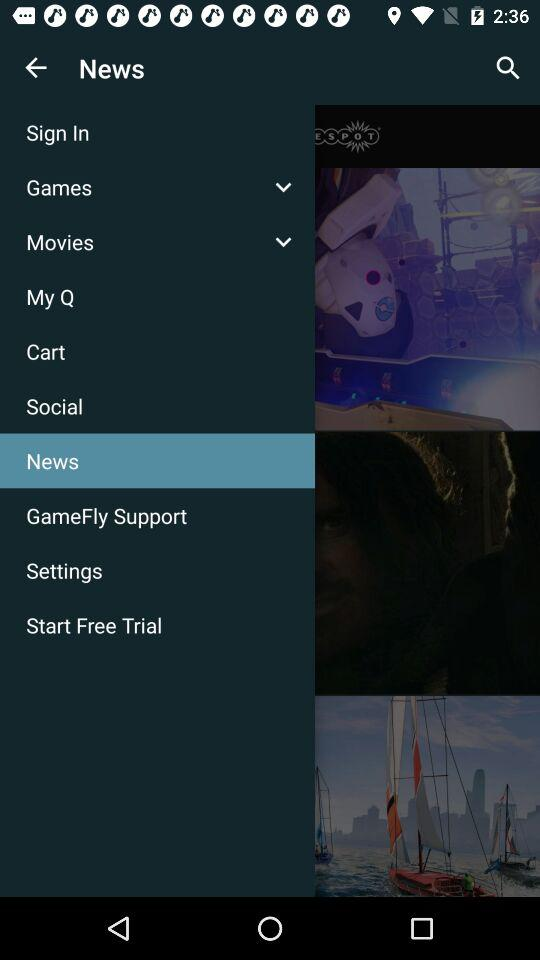How many notifications are there in "Social"?
When the provided information is insufficient, respond with <no answer>. <no answer> 